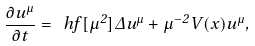<formula> <loc_0><loc_0><loc_500><loc_500>\frac { \partial u ^ { \mu } } { \partial t } = \ h f [ \mu ^ { 2 } ] \Delta u ^ { \mu } + \mu ^ { - 2 } V ( x ) u ^ { \mu } ,</formula> 